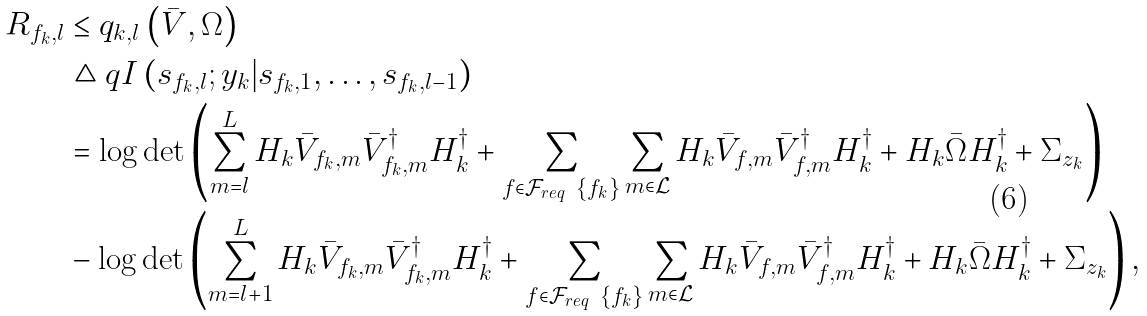Convert formula to latex. <formula><loc_0><loc_0><loc_500><loc_500>R _ { f _ { k } , l } & \leq q _ { k , l } \left ( \bar { V } , \Omega \right ) \\ & \triangle q I \left ( s _ { f _ { k } , l } ; y _ { k } | s _ { f _ { k } , 1 } , \dots , s _ { f _ { k } , l - 1 } \right ) \\ & = \log \det \left ( \sum _ { m = l } ^ { L } H _ { k } \bar { V } _ { f _ { k } , m } \bar { V } _ { f _ { k } , m } ^ { \dagger } H _ { k } ^ { \dagger } + \sum _ { f \in \mathcal { F } _ { r e q } \ \{ f _ { k } \} } \sum _ { m \in \mathcal { L } } H _ { k } \bar { V } _ { f , m } \bar { V } _ { f , m } ^ { \dagger } H _ { k } ^ { \dagger } + H _ { k } \bar { \Omega } H _ { k } ^ { \dagger } + \Sigma _ { z _ { k } } \right ) \\ & - \log \det \left ( \sum _ { m = l + 1 } ^ { L } H _ { k } \bar { V } _ { f _ { k } , m } \bar { V } _ { f _ { k } , m } ^ { \dagger } H _ { k } ^ { \dagger } + \sum _ { f \in \mathcal { F } _ { r e q } \ \{ f _ { k } \} } \sum _ { m \in \mathcal { L } } H _ { k } \bar { V } _ { f , m } \bar { V } _ { f , m } ^ { \dagger } H _ { k } ^ { \dagger } + H _ { k } \bar { \Omega } H _ { k } ^ { \dagger } + \Sigma _ { z _ { k } } \right ) ,</formula> 